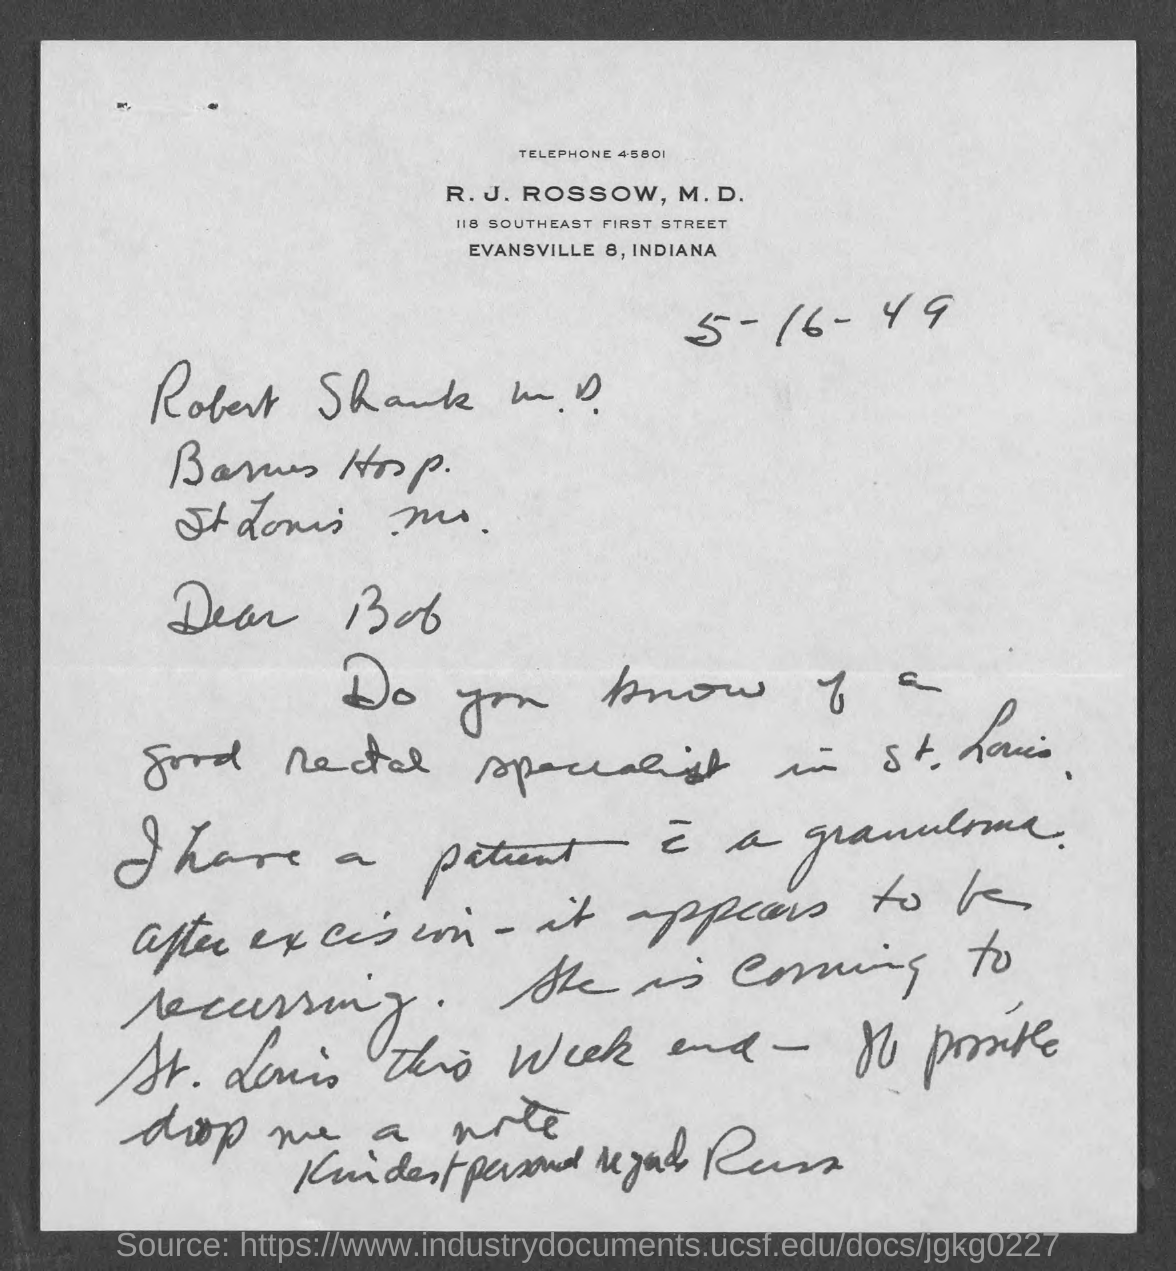What is the date mentioned in the given page ?
Keep it short and to the point. 5-16-49. What is the telephone no. mentioned in the given page ?
Ensure brevity in your answer.  45801. 